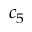Convert formula to latex. <formula><loc_0><loc_0><loc_500><loc_500>c _ { 5 }</formula> 